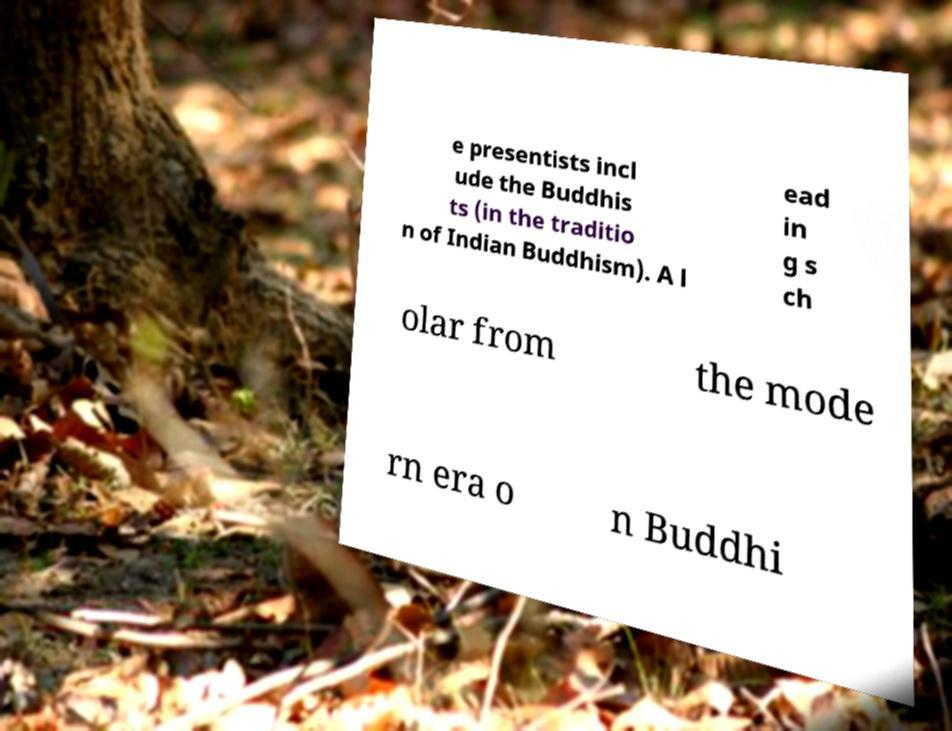For documentation purposes, I need the text within this image transcribed. Could you provide that? e presentists incl ude the Buddhis ts (in the traditio n of Indian Buddhism). A l ead in g s ch olar from the mode rn era o n Buddhi 